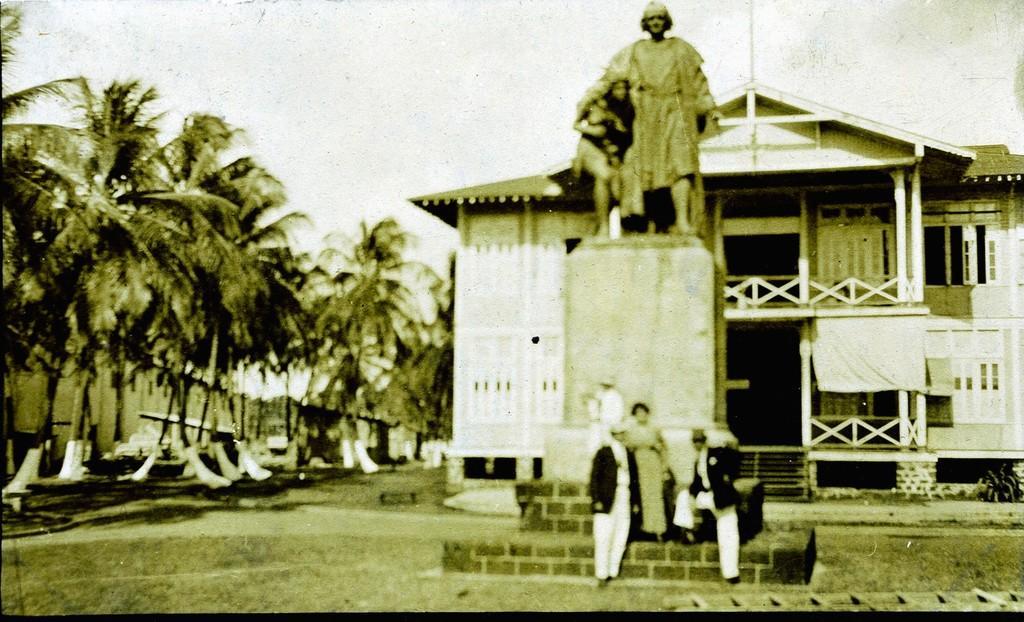Describe this image in one or two sentences. In this picture we can see three people. There is a statue. We can see a few trees and houses on the left side. There is a house behind the statue. 